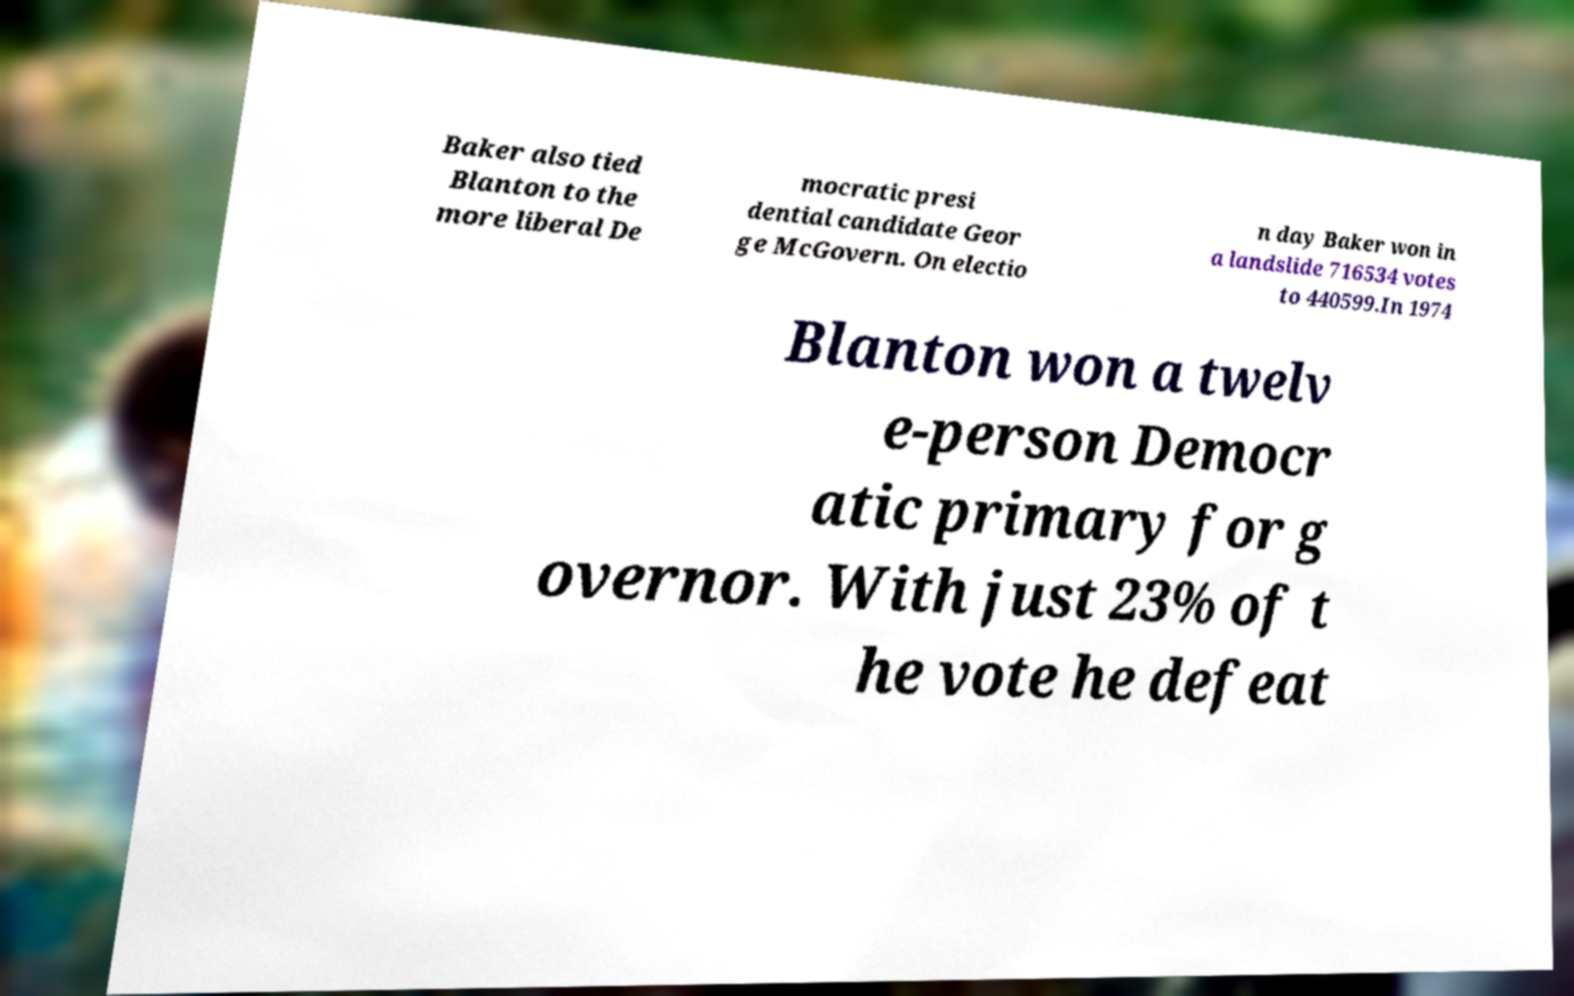Please read and relay the text visible in this image. What does it say? Baker also tied Blanton to the more liberal De mocratic presi dential candidate Geor ge McGovern. On electio n day Baker won in a landslide 716534 votes to 440599.In 1974 Blanton won a twelv e-person Democr atic primary for g overnor. With just 23% of t he vote he defeat 